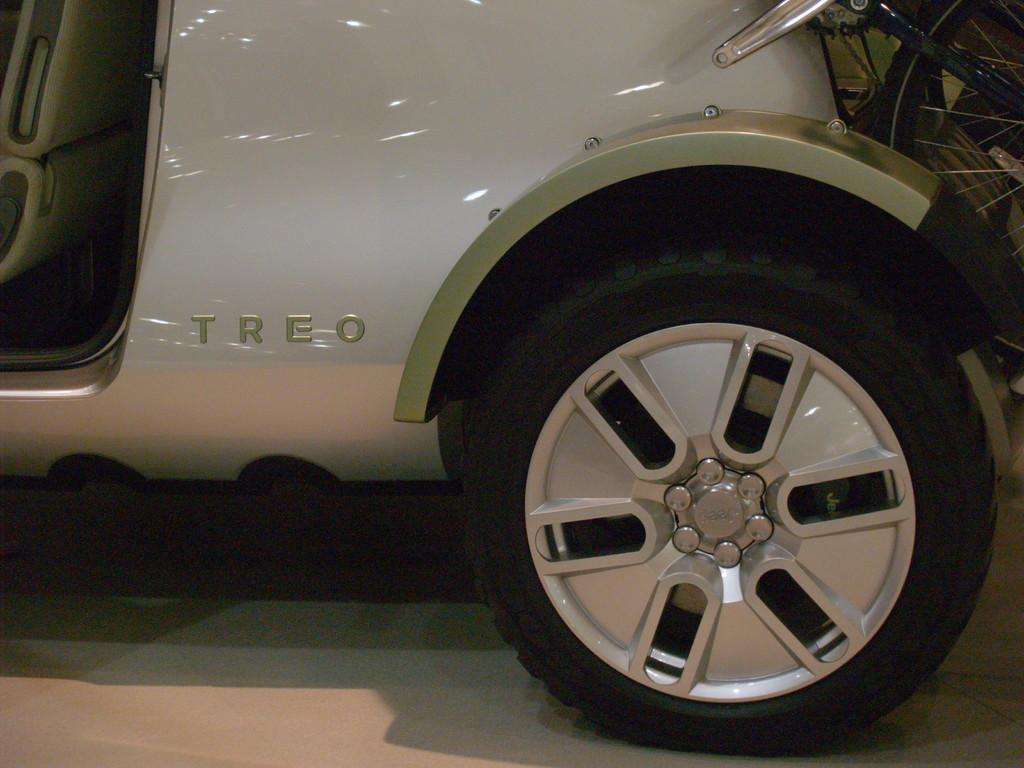What is the main subject of the image? The main subject of the image is a car. Where is the car located in the image? The car is on the ground in the image. What part of the car is mentioned in the facts? The fact mentions that there is a wheel attached to the car. What type of iron can be seen in the image? There is no iron present in the image; it features a car on the ground with a wheel attached. How many circles can be seen in the image? The image does not specifically mention circles, but the wheel attached to the car could be considered a circular object. 